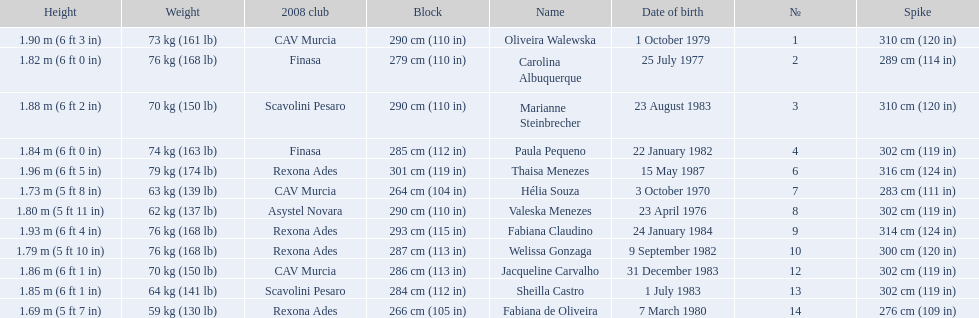What are all of the names? Oliveira Walewska, Carolina Albuquerque, Marianne Steinbrecher, Paula Pequeno, Thaisa Menezes, Hélia Souza, Valeska Menezes, Fabiana Claudino, Welissa Gonzaga, Jacqueline Carvalho, Sheilla Castro, Fabiana de Oliveira. What are their weights? 73 kg (161 lb), 76 kg (168 lb), 70 kg (150 lb), 74 kg (163 lb), 79 kg (174 lb), 63 kg (139 lb), 62 kg (137 lb), 76 kg (168 lb), 76 kg (168 lb), 70 kg (150 lb), 64 kg (141 lb), 59 kg (130 lb). How much did helia souza, fabiana de oliveira, and sheilla castro weigh? Hélia Souza, Sheilla Castro, Fabiana de Oliveira. And who weighed more? Sheilla Castro. 